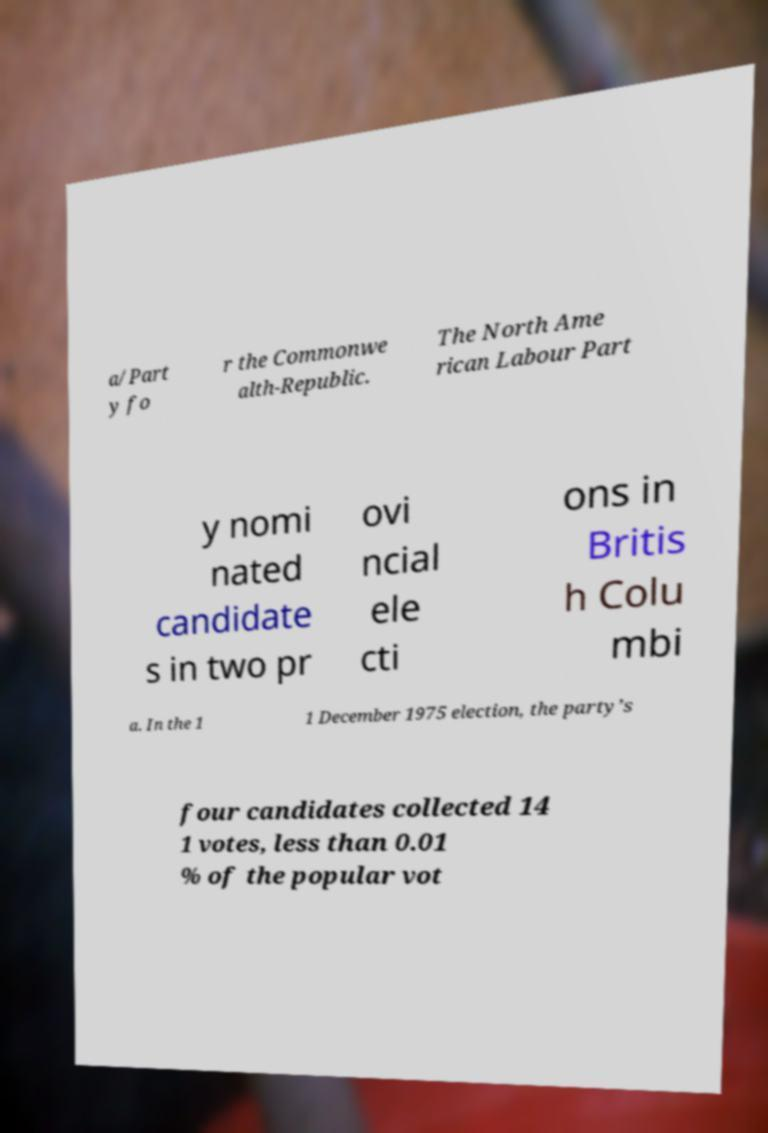I need the written content from this picture converted into text. Can you do that? a/Part y fo r the Commonwe alth-Republic. The North Ame rican Labour Part y nomi nated candidate s in two pr ovi ncial ele cti ons in Britis h Colu mbi a. In the 1 1 December 1975 election, the party’s four candidates collected 14 1 votes, less than 0.01 % of the popular vot 